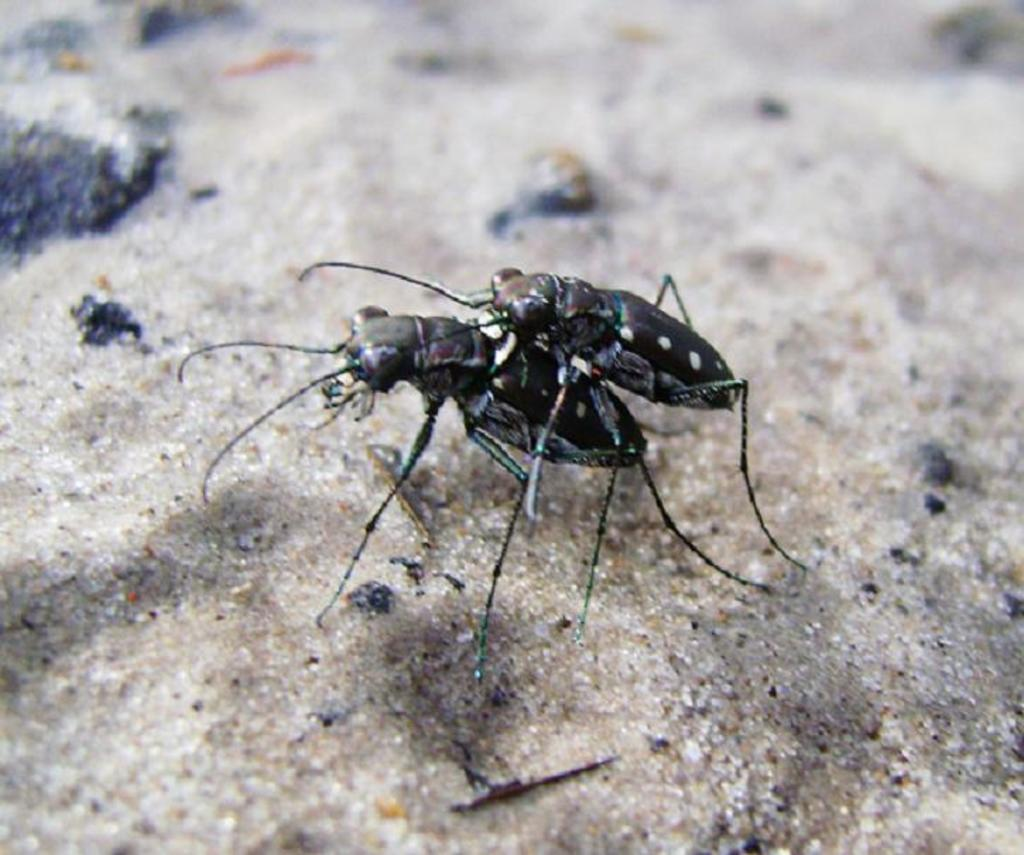What type of creatures are present in the image? There are two black color insects in the image. How would you describe the quality of the background in the image? The image is blurry in the background. What color can be observed in the image? There are black color things visible in the image. Can you see any pencils floating in the ocean in the image? There is no ocean or pencils present in the image; it features two black color insects and a blurry background. 